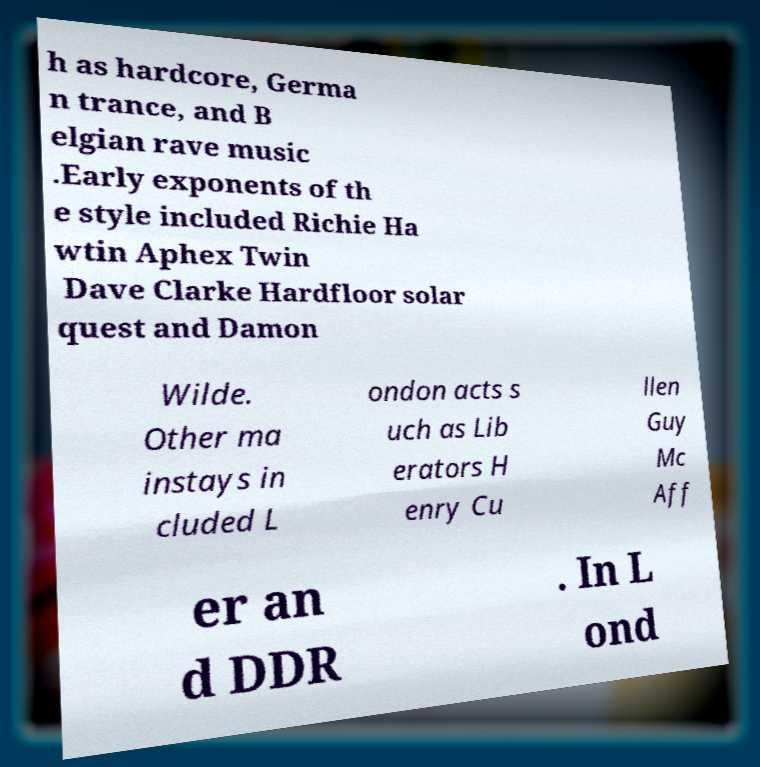What messages or text are displayed in this image? I need them in a readable, typed format. h as hardcore, Germa n trance, and B elgian rave music .Early exponents of th e style included Richie Ha wtin Aphex Twin Dave Clarke Hardfloor solar quest and Damon Wilde. Other ma instays in cluded L ondon acts s uch as Lib erators H enry Cu llen Guy Mc Aff er an d DDR . In L ond 